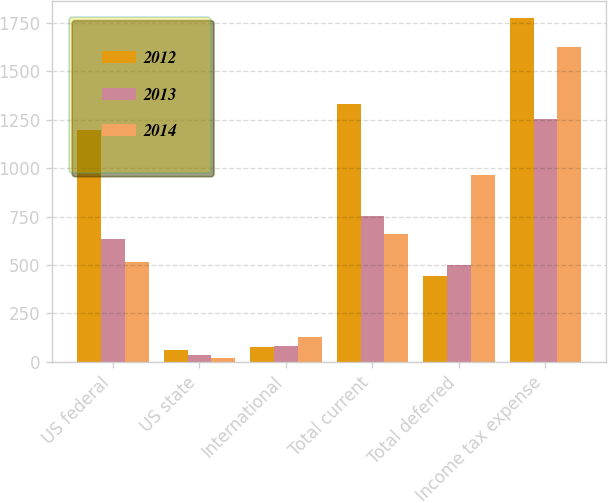Convert chart. <chart><loc_0><loc_0><loc_500><loc_500><stacked_bar_chart><ecel><fcel>US federal<fcel>US state<fcel>International<fcel>Total current<fcel>Total deferred<fcel>Income tax expense<nl><fcel>2012<fcel>1196<fcel>59<fcel>77<fcel>1332<fcel>445<fcel>1777<nl><fcel>2013<fcel>635<fcel>36<fcel>82<fcel>753<fcel>501<fcel>1254<nl><fcel>2014<fcel>515<fcel>22<fcel>126<fcel>663<fcel>963<fcel>1626<nl></chart> 